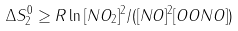Convert formula to latex. <formula><loc_0><loc_0><loc_500><loc_500>\Delta S _ { 2 } ^ { 0 } \geq R \ln { [ N O _ { 2 } ] ^ { 2 } / ( [ N O ] ^ { 2 } [ O O N O ] ) }</formula> 